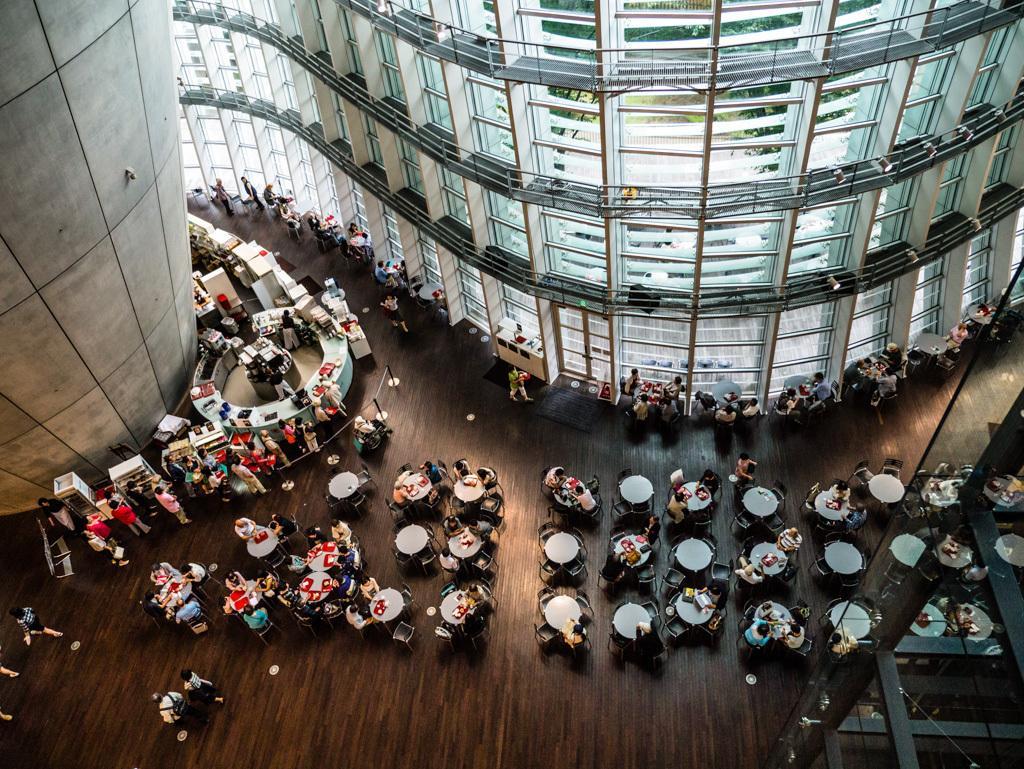In one or two sentences, can you explain what this image depicts? The picture is taken inside a building. On the floor there are many tables and chairs. People are sitting on the chairs. Here there are many counters. In the background wall, building, windows made up of glass are there. 